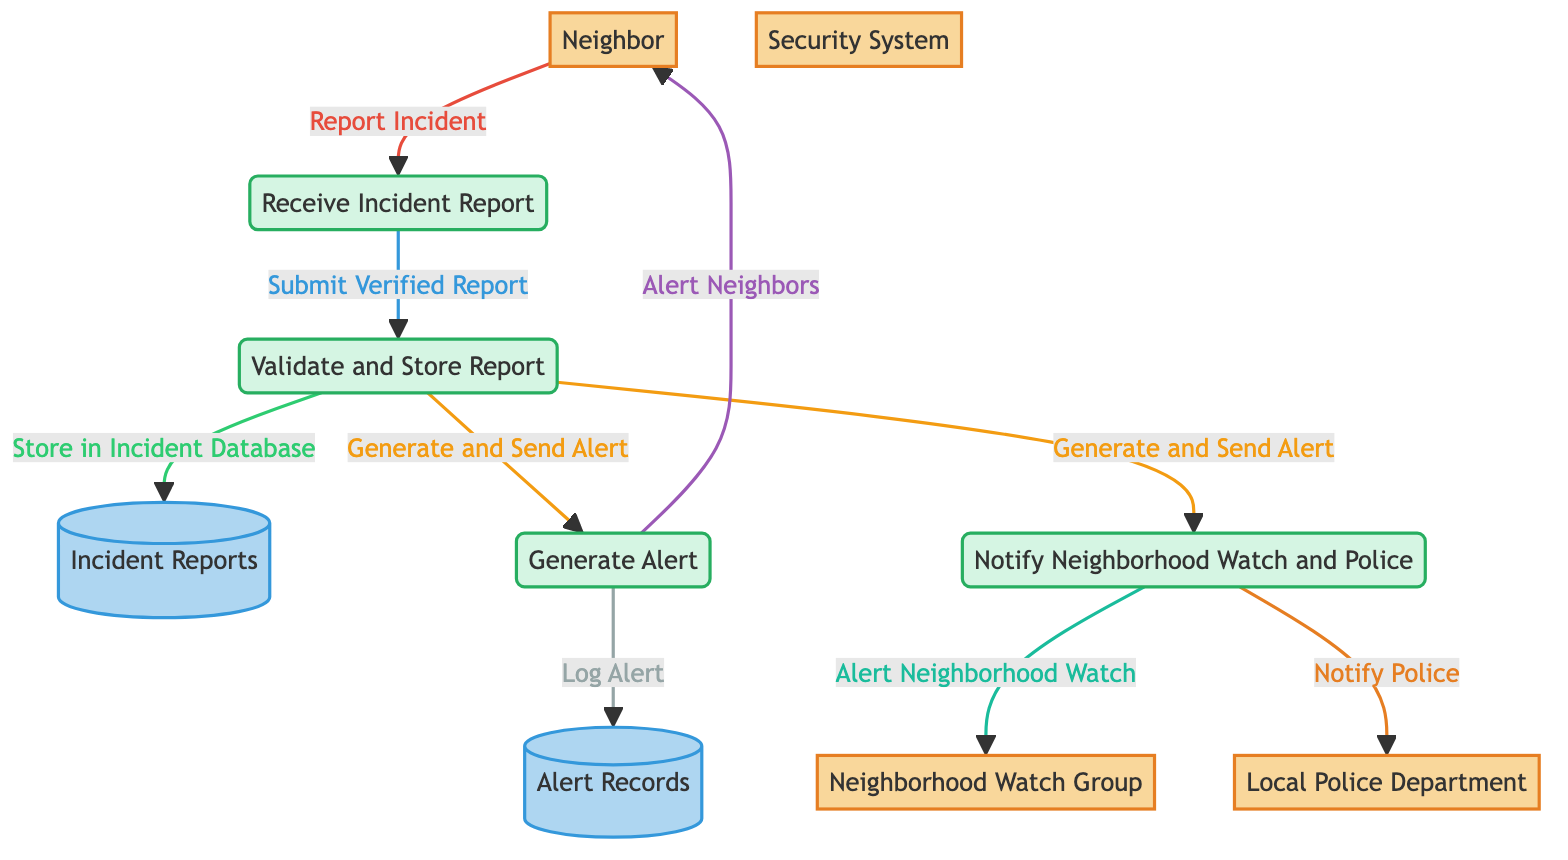What does the Neighbor do? The Neighbor reports incidents to the "Receive Incident Report" process, beginning the flow of information in the diagram.
Answer: report incident How many processes are present in the diagram? There are four distinct processes shown within the data flow diagram: "Receive Incident Report," "Validate and Store Report," "Generate Alert," and "Notify Neighborhood Watch and Police."
Answer: four Who receives alerts about incidents? Alerts generated from the "Generate Alert" process are sent to the Neighbor, while critical incidents are communicated to both the Neighborhood Watch Group and the Local Police Department through the "Notify Neighborhood Watch and Police" process.
Answer: Neighbor, Neighborhood Watch Group, Local Police Department What happens after the incident is reported by the Neighbor? Once the incident is reported by the Neighbor, it moves to the "Receive Incident Report," after which it is submitted for validation and storage in the database, meaning the next step is "Submit Verified Report."
Answer: submit verified report What does the "Validate and Store Report" process do? This process checks the completeness and accuracy of the incident report and subsequently stores the validated report in the "Incident Reports" database.
Answer: checks for completeness and accuracy 